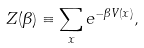Convert formula to latex. <formula><loc_0><loc_0><loc_500><loc_500>Z ( \beta ) \equiv \sum _ { x } e ^ { - \beta V ( { x } ) } ,</formula> 